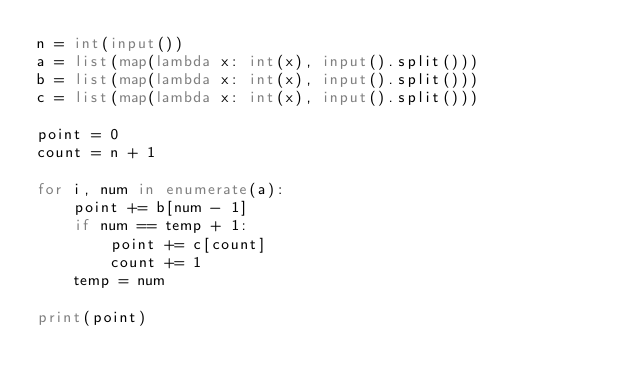<code> <loc_0><loc_0><loc_500><loc_500><_Python_>n = int(input())
a = list(map(lambda x: int(x), input().split()))
b = list(map(lambda x: int(x), input().split()))
c = list(map(lambda x: int(x), input().split()))

point = 0
count = n + 1

for i, num in enumerate(a):
    point += b[num - 1]
    if num == temp + 1:
        point += c[count]
        count += 1
    temp = num

print(point)

</code> 